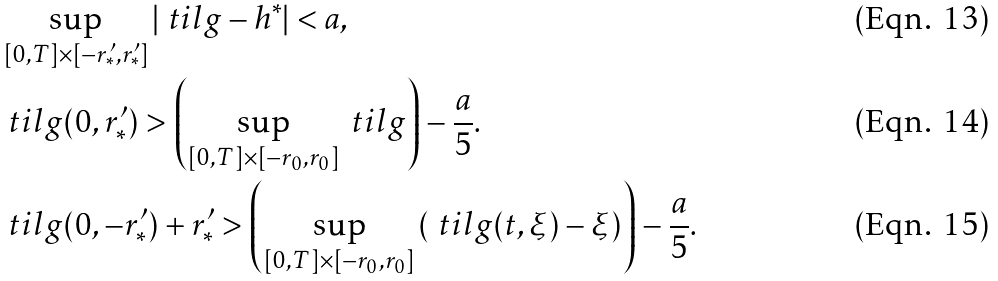Convert formula to latex. <formula><loc_0><loc_0><loc_500><loc_500>& \sup _ { [ 0 , T ] \times [ - { r ^ { \prime } _ { * } } , { r ^ { \prime } _ { * } } ] } | \ t i l g - h ^ { * } | < a , \\ & \ t i l g ( 0 , { r ^ { \prime } _ { * } } ) > \left ( \sup _ { [ 0 , T ] \times [ - r _ { 0 } , r _ { 0 } ] } \ t i l g \right ) - \frac { a } { 5 } . \\ & \ t i l g ( 0 , - { r ^ { \prime } _ { * } } ) + r ^ { \prime } _ { * } > \left ( \sup _ { [ 0 , T ] \times [ - r _ { 0 } , r _ { 0 } ] } \left ( \ t i l g ( t , \xi ) - \xi \right ) \right ) - \frac { a } { 5 } .</formula> 